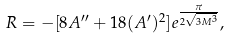<formula> <loc_0><loc_0><loc_500><loc_500>R = - [ 8 A ^ { \prime \prime } + 1 8 ( A ^ { \prime } ) ^ { 2 } ] e ^ { \frac { \pi } { 2 \sqrt { 3 M ^ { 3 } } } } ,</formula> 